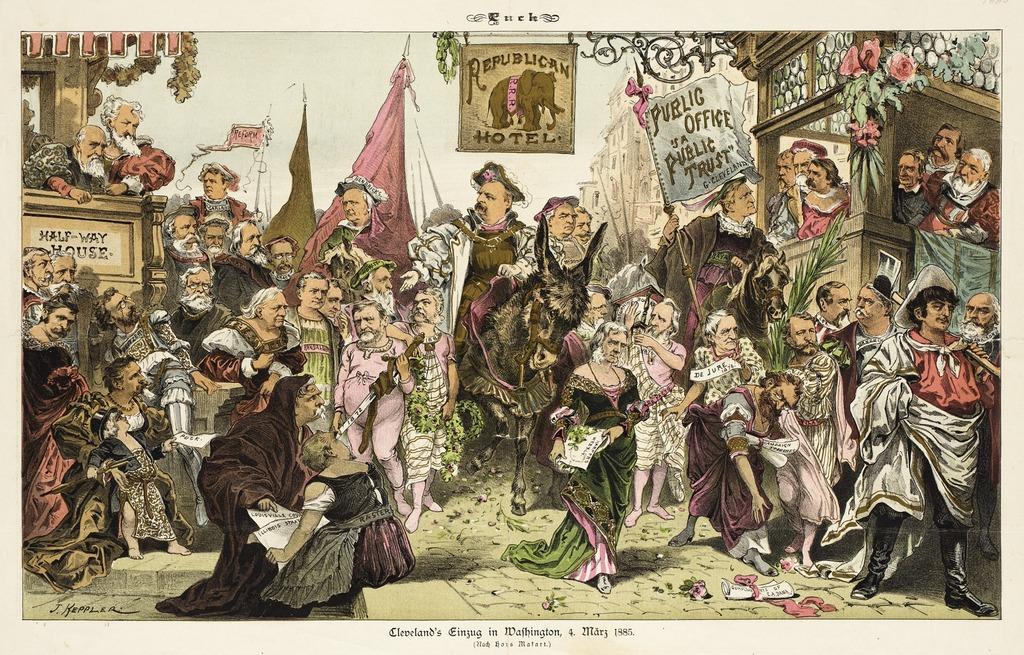What is the name of the hotel?
Make the answer very short. Republican. Is there a hotel there?
Offer a very short reply. Yes. 